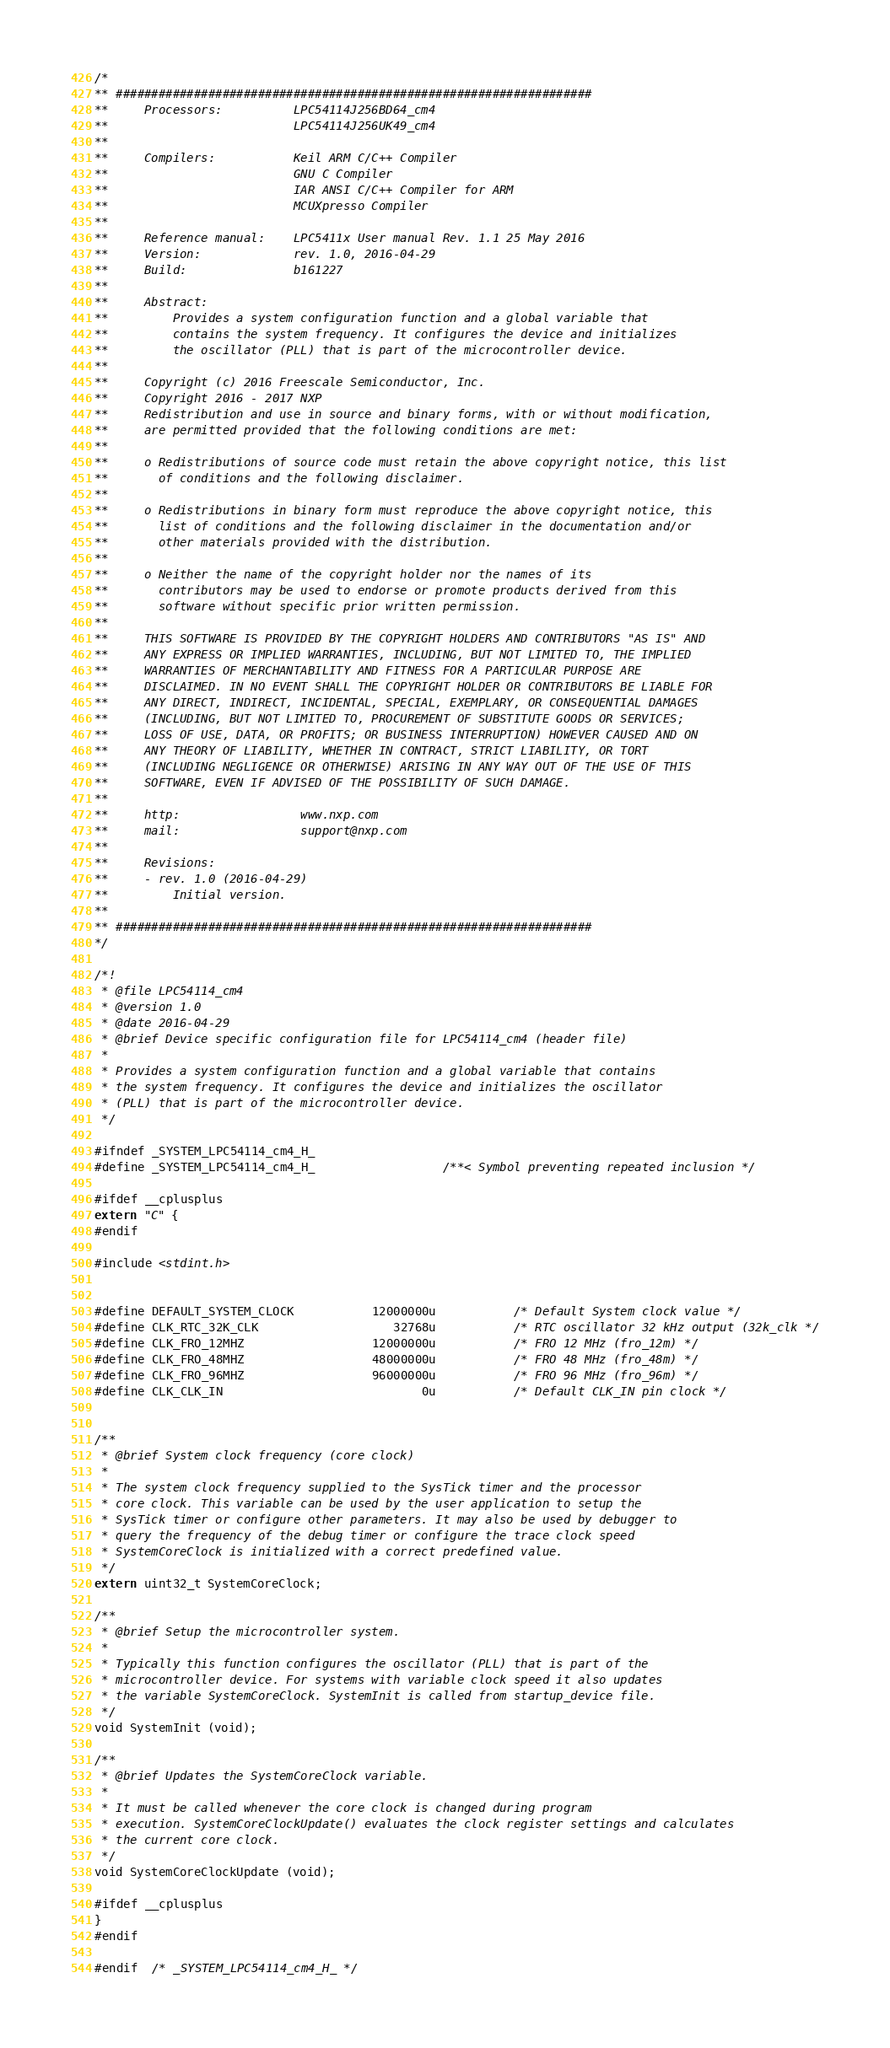Convert code to text. <code><loc_0><loc_0><loc_500><loc_500><_C_>/*
** ###################################################################
**     Processors:          LPC54114J256BD64_cm4
**                          LPC54114J256UK49_cm4
**
**     Compilers:           Keil ARM C/C++ Compiler
**                          GNU C Compiler
**                          IAR ANSI C/C++ Compiler for ARM
**                          MCUXpresso Compiler
**
**     Reference manual:    LPC5411x User manual Rev. 1.1 25 May 2016
**     Version:             rev. 1.0, 2016-04-29
**     Build:               b161227
**
**     Abstract:
**         Provides a system configuration function and a global variable that
**         contains the system frequency. It configures the device and initializes
**         the oscillator (PLL) that is part of the microcontroller device.
**
**     Copyright (c) 2016 Freescale Semiconductor, Inc.
**     Copyright 2016 - 2017 NXP
**     Redistribution and use in source and binary forms, with or without modification,
**     are permitted provided that the following conditions are met:
**
**     o Redistributions of source code must retain the above copyright notice, this list
**       of conditions and the following disclaimer.
**
**     o Redistributions in binary form must reproduce the above copyright notice, this
**       list of conditions and the following disclaimer in the documentation and/or
**       other materials provided with the distribution.
**
**     o Neither the name of the copyright holder nor the names of its
**       contributors may be used to endorse or promote products derived from this
**       software without specific prior written permission.
**
**     THIS SOFTWARE IS PROVIDED BY THE COPYRIGHT HOLDERS AND CONTRIBUTORS "AS IS" AND
**     ANY EXPRESS OR IMPLIED WARRANTIES, INCLUDING, BUT NOT LIMITED TO, THE IMPLIED
**     WARRANTIES OF MERCHANTABILITY AND FITNESS FOR A PARTICULAR PURPOSE ARE
**     DISCLAIMED. IN NO EVENT SHALL THE COPYRIGHT HOLDER OR CONTRIBUTORS BE LIABLE FOR
**     ANY DIRECT, INDIRECT, INCIDENTAL, SPECIAL, EXEMPLARY, OR CONSEQUENTIAL DAMAGES
**     (INCLUDING, BUT NOT LIMITED TO, PROCUREMENT OF SUBSTITUTE GOODS OR SERVICES;
**     LOSS OF USE, DATA, OR PROFITS; OR BUSINESS INTERRUPTION) HOWEVER CAUSED AND ON
**     ANY THEORY OF LIABILITY, WHETHER IN CONTRACT, STRICT LIABILITY, OR TORT
**     (INCLUDING NEGLIGENCE OR OTHERWISE) ARISING IN ANY WAY OUT OF THE USE OF THIS
**     SOFTWARE, EVEN IF ADVISED OF THE POSSIBILITY OF SUCH DAMAGE.
**
**     http:                 www.nxp.com
**     mail:                 support@nxp.com
**
**     Revisions:
**     - rev. 1.0 (2016-04-29)
**         Initial version.
**
** ###################################################################
*/

/*!
 * @file LPC54114_cm4
 * @version 1.0
 * @date 2016-04-29
 * @brief Device specific configuration file for LPC54114_cm4 (header file)
 *
 * Provides a system configuration function and a global variable that contains
 * the system frequency. It configures the device and initializes the oscillator
 * (PLL) that is part of the microcontroller device.
 */

#ifndef _SYSTEM_LPC54114_cm4_H_
#define _SYSTEM_LPC54114_cm4_H_                  /**< Symbol preventing repeated inclusion */

#ifdef __cplusplus
extern "C" {
#endif

#include <stdint.h>


#define DEFAULT_SYSTEM_CLOCK           12000000u           /* Default System clock value */
#define CLK_RTC_32K_CLK                   32768u           /* RTC oscillator 32 kHz output (32k_clk */
#define CLK_FRO_12MHZ                  12000000u           /* FRO 12 MHz (fro_12m) */
#define CLK_FRO_48MHZ                  48000000u           /* FRO 48 MHz (fro_48m) */
#define CLK_FRO_96MHZ                  96000000u           /* FRO 96 MHz (fro_96m) */
#define CLK_CLK_IN                            0u           /* Default CLK_IN pin clock */


/**
 * @brief System clock frequency (core clock)
 *
 * The system clock frequency supplied to the SysTick timer and the processor
 * core clock. This variable can be used by the user application to setup the
 * SysTick timer or configure other parameters. It may also be used by debugger to
 * query the frequency of the debug timer or configure the trace clock speed
 * SystemCoreClock is initialized with a correct predefined value.
 */
extern uint32_t SystemCoreClock;

/**
 * @brief Setup the microcontroller system.
 *
 * Typically this function configures the oscillator (PLL) that is part of the
 * microcontroller device. For systems with variable clock speed it also updates
 * the variable SystemCoreClock. SystemInit is called from startup_device file.
 */
void SystemInit (void);

/**
 * @brief Updates the SystemCoreClock variable.
 *
 * It must be called whenever the core clock is changed during program
 * execution. SystemCoreClockUpdate() evaluates the clock register settings and calculates
 * the current core clock.
 */
void SystemCoreClockUpdate (void);

#ifdef __cplusplus
}
#endif

#endif  /* _SYSTEM_LPC54114_cm4_H_ */
</code> 